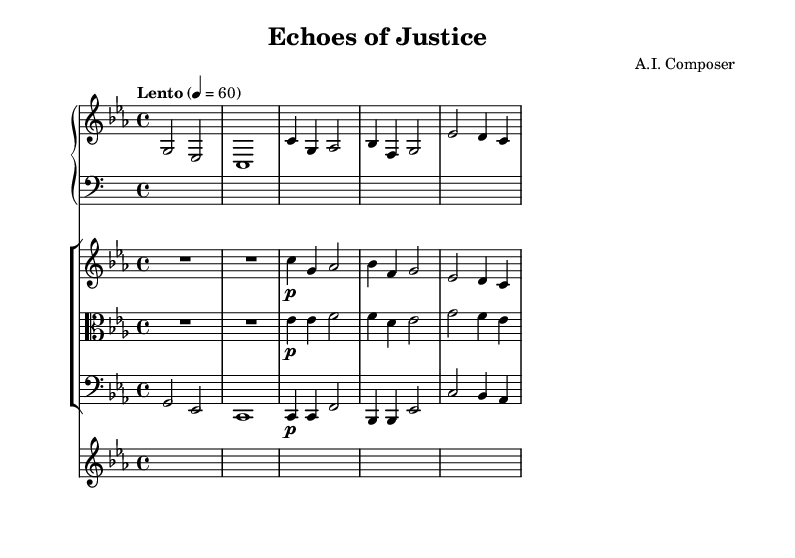What is the key signature of this music? The key signature is C minor, which has three flats (B flat, E flat, and A flat). This can be identified on the left side of the staff, showing the specific flats for the C minor scale.
Answer: C minor What is the time signature of this score? The time signature is shown at the beginning of the score and is notated as 4/4, which means there are four beats in each measure and the quarter note gets the beat.
Answer: 4/4 What is the tempo marking for this piece? The tempo marking at the beginning indicates "Lento," which means slow. Additionally, it specifies the beat as 60 beats per minute.
Answer: Lento How many total instruments are featured in this score? By looking at the individual staff sections, we can see there are four distinct instruments: Piano, Violin, Viola, and Cello, along with a Synth. Thus, a total of five instruments.
Answer: 5 What type of musical piece is indicated by the title at the top? The title "Echoes of Justice" suggests it is an atmospheric ambient soundtrack suited for a courtroom thriller. The term 'Echoes' hints at a reflective or suspenseful character, typical in such soundtracks.
Answer: Soundtrack What is the primary motif in the main theme for the piano? The main theme for the piano begins with notes C, G, A flat, B flat, F, and G, indicating a melodic sequence that sets the thematic material. This can be observed in the notation under the section labeled "Main Theme."
Answer: C, G, A flat, B flat, F, G What dynamic marking is used for the violin during the main theme? The dynamic marking for the violin is indicated as "p," which stands for piano, meaning to play softly. This marking is located next to the notes in the main theme section of the violin part.
Answer: piano 